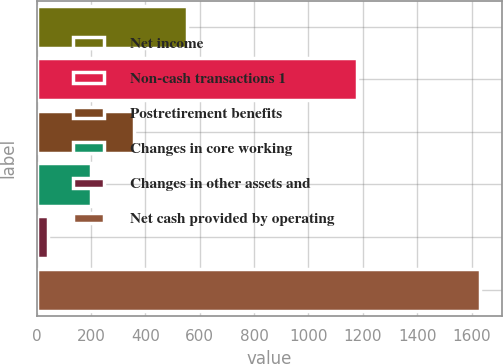Convert chart. <chart><loc_0><loc_0><loc_500><loc_500><bar_chart><fcel>Net income<fcel>Non-cash transactions 1<fcel>Postretirement benefits<fcel>Changes in core working<fcel>Changes in other assets and<fcel>Net cash provided by operating<nl><fcel>553<fcel>1177<fcel>360.2<fcel>201.6<fcel>43<fcel>1629<nl></chart> 